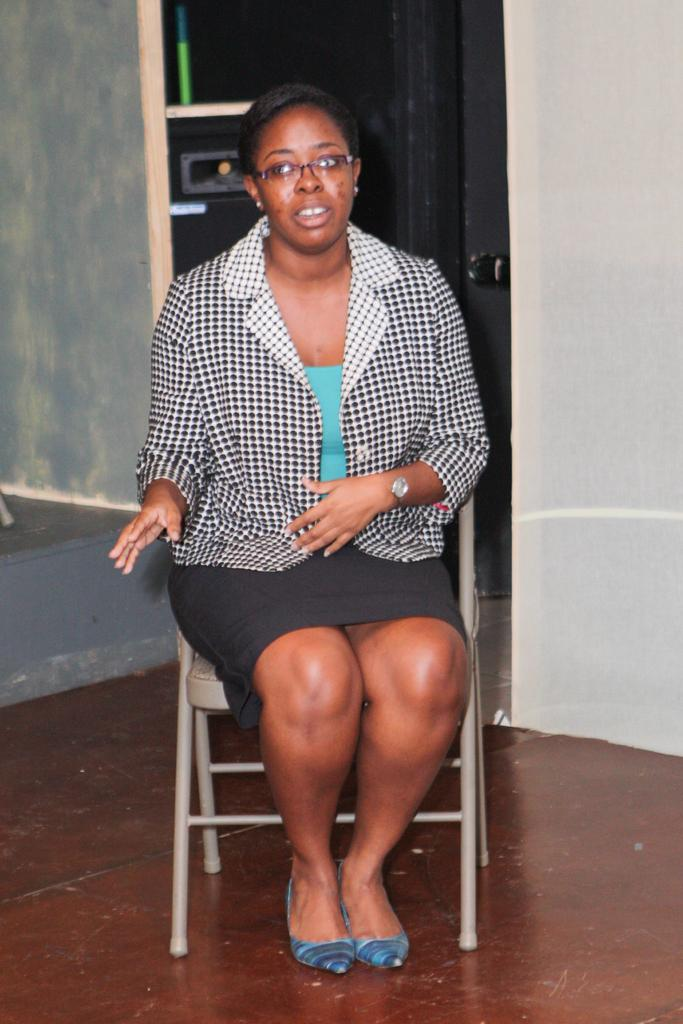Who is the main subject in the image? There is a woman in the image. What is the woman wearing? The woman is wearing a black and white blazer. What accessory is the woman wearing? The woman is wearing specs. What is the woman's position in the image? The woman is sitting on a chair. What can be seen in the background of the image? There is a white color wall in the background of the image. What type of club does the woman belong to in the image? There is no indication in the image that the woman belongs to any club. 